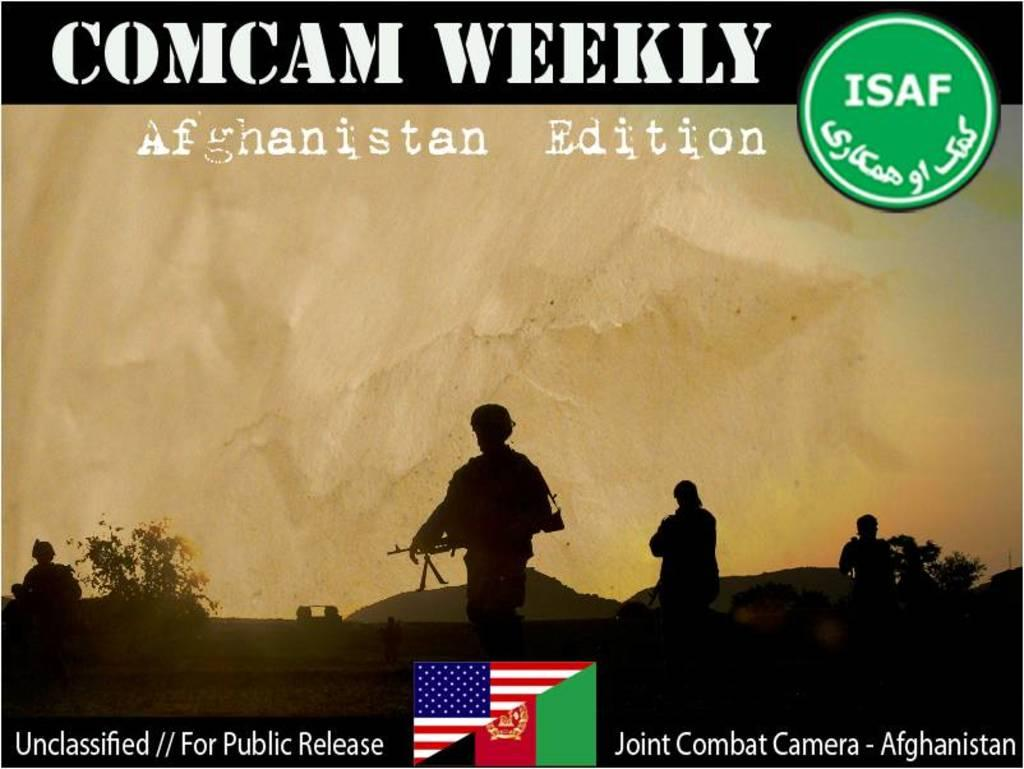<image>
Render a clear and concise summary of the photo. Comcam weekly Afghanistan Edition has shadows of soldiers on it. 